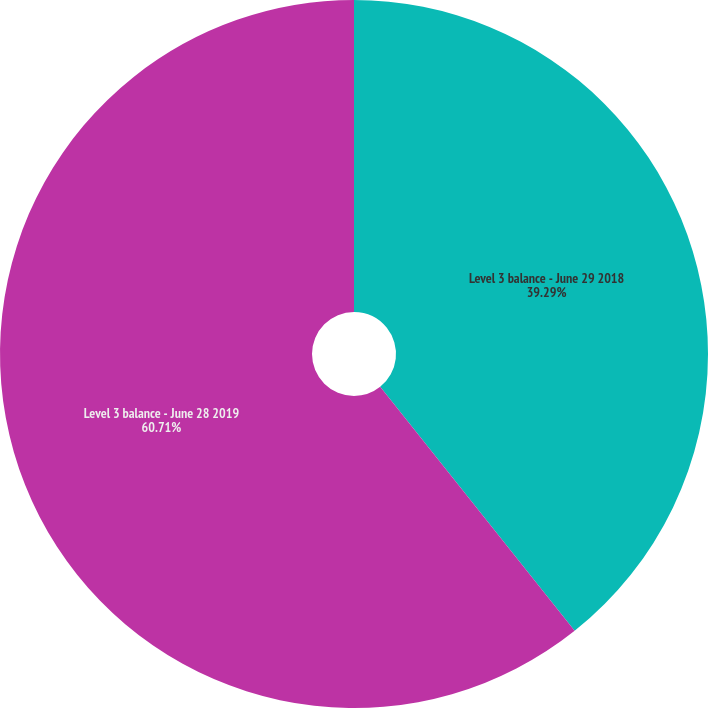Convert chart to OTSL. <chart><loc_0><loc_0><loc_500><loc_500><pie_chart><fcel>Level 3 balance - June 29 2018<fcel>Level 3 balance - June 28 2019<nl><fcel>39.29%<fcel>60.71%<nl></chart> 